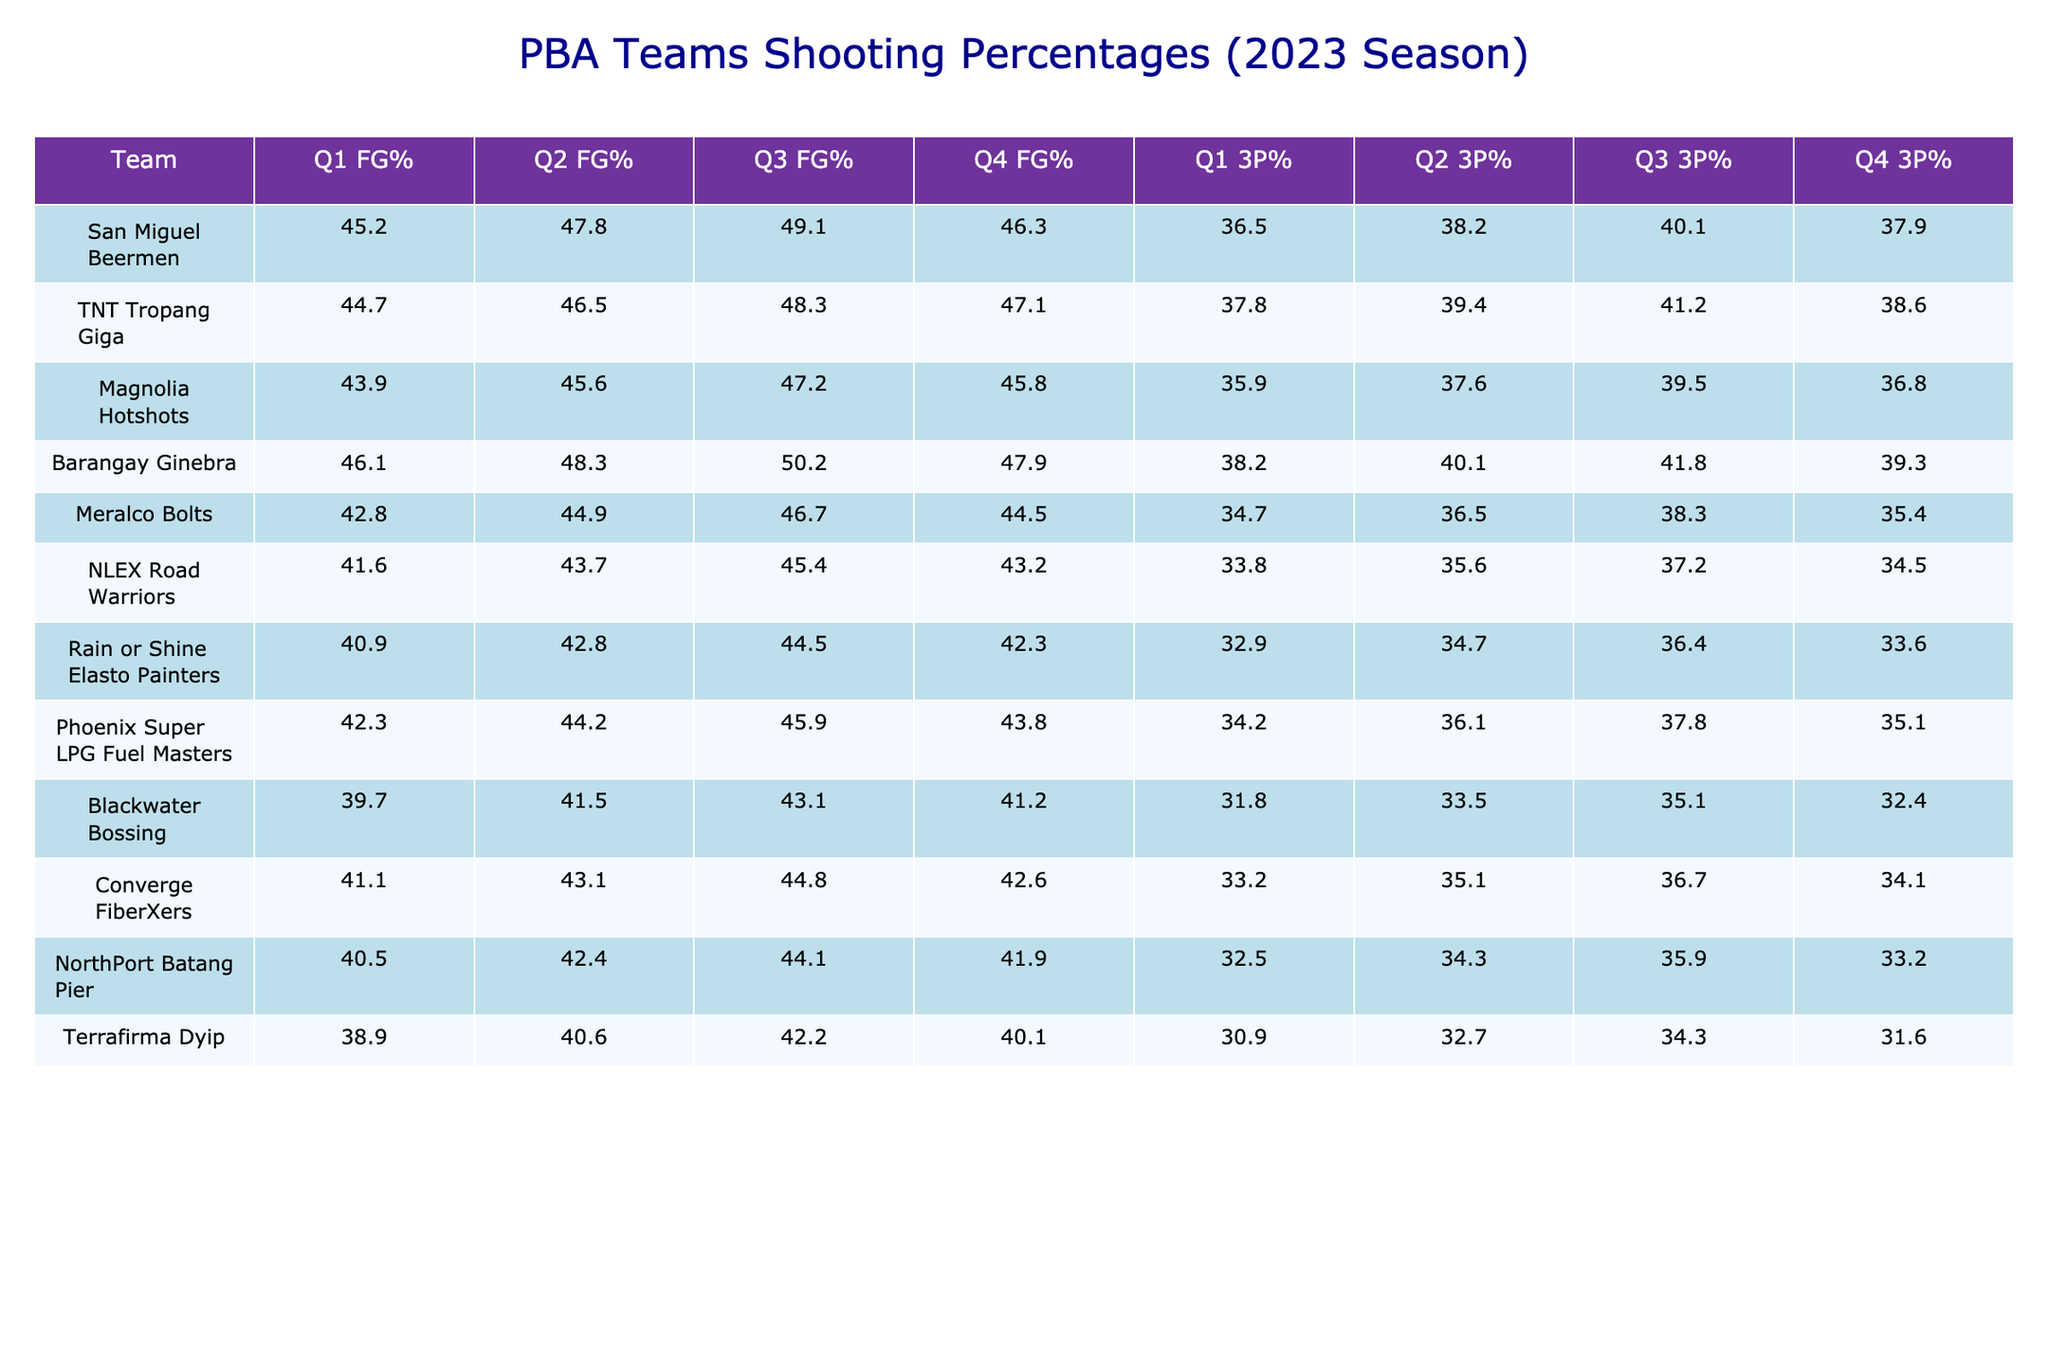What is the shooting percentage of San Miguel Beermen in Q1? According to the table, the shooting percentage for San Miguel Beermen in Q1 is 45.2.
Answer: 45.2 Which team had the highest shooting percentage in Q3? By looking at the Q3 FG% column, Barangay Ginebra has the highest value at 50.2.
Answer: Barangay Ginebra What is the average 3-point shooting percentage across all teams in Q4? First, I will sum the Q4 3P% values: (37.9 + 38.6 + 36.8 + 39.3 + 35.4 + 34.5 + 33.6 + 35.1 + 32.4 + 34.1 + 33.2 + 31.6) = 434.6. There are 12 teams, so the average is 434.6 / 12 = 36.2167, which rounds to 36.22.
Answer: 36.22 Did any team shoot better than 40% from 3-point range in all quarters? By checking the 3P% for each team across all quarters, only San Miguel Beermen and Barangay Ginebra have all quarters above 40%: San Miguel Beermen (36.5, 38.2, 40.1, 37.9) and Barangay Ginebra (38.2, 40.1, 41.8, 39.3). So, the answer is yes, as both teams consistently shot above 40% in all quarters.
Answer: Yes Which team improved its FG% from Q1 to Q2 the most? By calculating the difference between Q2 and Q1 for each team: San Miguel Beermen (2.6), TNT Tropang Giga (1.8), Magnolia Hotshots (1.7), Barangay Ginebra (2.2), Meralco Bolts (2.1), NLEX Road Warriors (2.1), Rain or Shine Elasto Painters (1.9), Phoenix Super LPG Fuel Masters (1.9), Blackwater Bossing (1.8), Converge FiberXers (2.0), NorthPort Batang Pier (1.9), Terrafirma Dyip (1.7). The maximum increase is for San Miguel Beermen with an increase of 2.6%.
Answer: San Miguel Beermen 